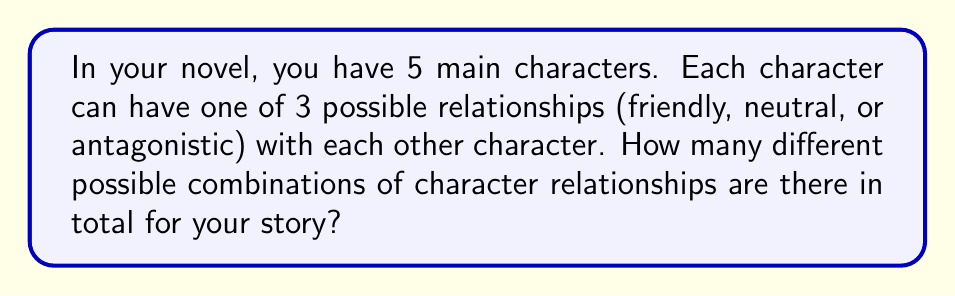What is the answer to this math problem? Let's approach this step-by-step:

1) First, we need to determine how many relationships we're considering:
   - With 5 characters, each character has a relationship with 4 others.
   - The total number of relationships is: $\frac{5 \times 4}{2} = 10$ (we divide by 2 to avoid counting each relationship twice)

2) For each of these 10 relationships, there are 3 possibilities (friendly, neutral, or antagonistic).

3) This scenario can be modeled as a combination with repetition problem. We're essentially making 10 independent choices, each with 3 options.

4) The formula for this is:

   $$ \text{Total combinations} = 3^{10} $$

5) Let's calculate:

   $$ 3^{10} = 3 \times 3 \times 3 \times 3 \times 3 \times 3 \times 3 \times 3 \times 3 \times 3 = 59,049 $$

Therefore, there are 59,049 different possible combinations of character relationships for your story.
Answer: 59,049 